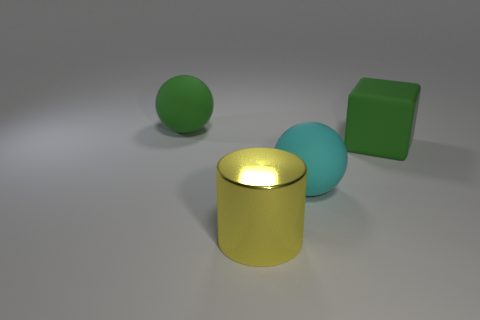Subtract all cylinders. How many objects are left? 3 Add 3 tiny metal cylinders. How many objects exist? 7 Subtract 2 spheres. How many spheres are left? 0 Subtract all brown blocks. How many green cylinders are left? 0 Subtract all large yellow metal cylinders. Subtract all big cyan metallic balls. How many objects are left? 3 Add 2 big cyan matte spheres. How many big cyan matte spheres are left? 3 Add 2 big red spheres. How many big red spheres exist? 2 Subtract 0 red cubes. How many objects are left? 4 Subtract all red blocks. Subtract all yellow cylinders. How many blocks are left? 1 